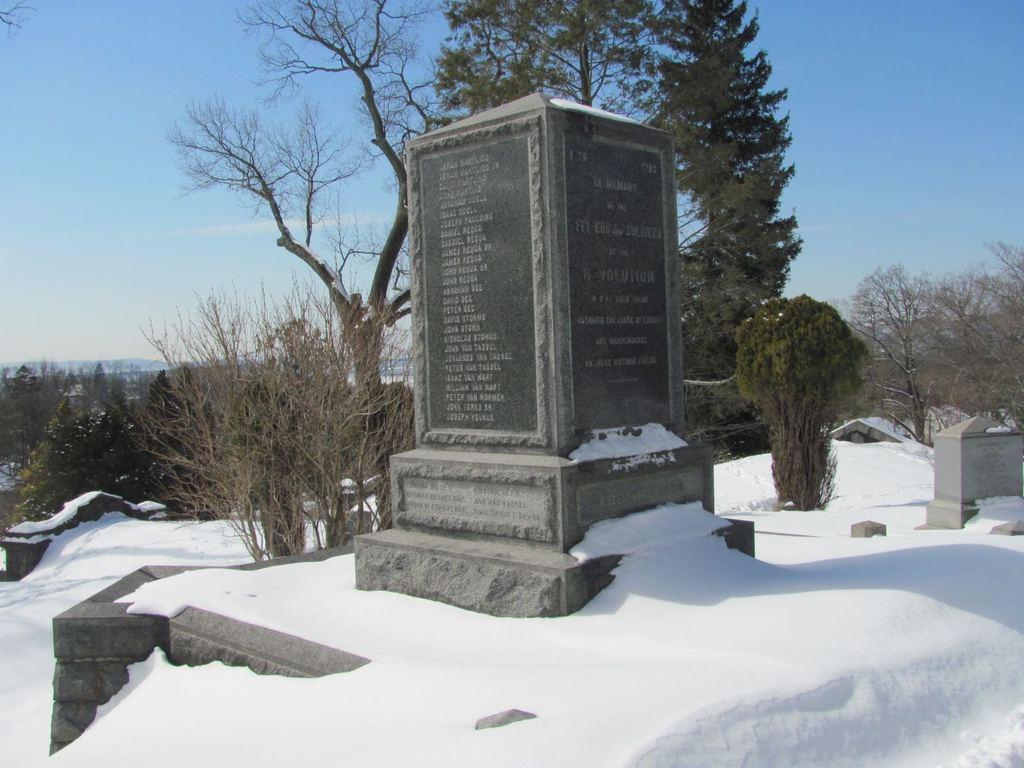What type of vegetation can be seen in the image? There are trees and plants in the image. Can you describe any specific features of the vegetation? There is a stone with writing on it in the image. What is the weather like in the image? There is snow in the image, indicating a cold environment. What can be seen in the background of the image? The sky is visible in the background of the image. Can you hear the soup boiling in the image? There is no soup present in the image, and therefore no boiling sound can be heard. 